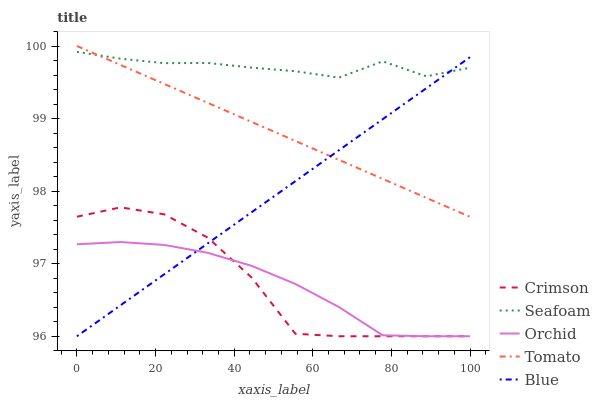Does Orchid have the minimum area under the curve?
Answer yes or no. Yes. Does Seafoam have the maximum area under the curve?
Answer yes or no. Yes. Does Tomato have the minimum area under the curve?
Answer yes or no. No. Does Tomato have the maximum area under the curve?
Answer yes or no. No. Is Blue the smoothest?
Answer yes or no. Yes. Is Crimson the roughest?
Answer yes or no. Yes. Is Tomato the smoothest?
Answer yes or no. No. Is Tomato the roughest?
Answer yes or no. No. Does Tomato have the lowest value?
Answer yes or no. No. Does Tomato have the highest value?
Answer yes or no. Yes. Does Seafoam have the highest value?
Answer yes or no. No. Is Orchid less than Tomato?
Answer yes or no. Yes. Is Tomato greater than Orchid?
Answer yes or no. Yes. Does Orchid intersect Tomato?
Answer yes or no. No. 